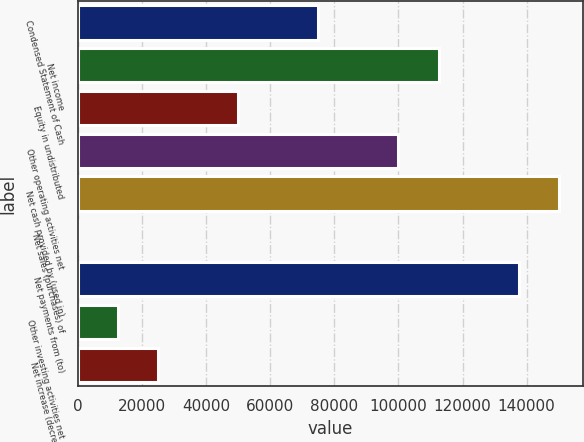Convert chart to OTSL. <chart><loc_0><loc_0><loc_500><loc_500><bar_chart><fcel>Condensed Statement of Cash<fcel>Net income<fcel>Equity in undistributed<fcel>Other operating activities net<fcel>Net cash provided by (used in)<fcel>Net sales (purchases) of<fcel>Net payments from (to)<fcel>Other investing activities net<fcel>Net increase (decrease) in<nl><fcel>74999.8<fcel>112493<fcel>50004.2<fcel>99995.4<fcel>149987<fcel>13<fcel>137489<fcel>12510.8<fcel>25008.6<nl></chart> 